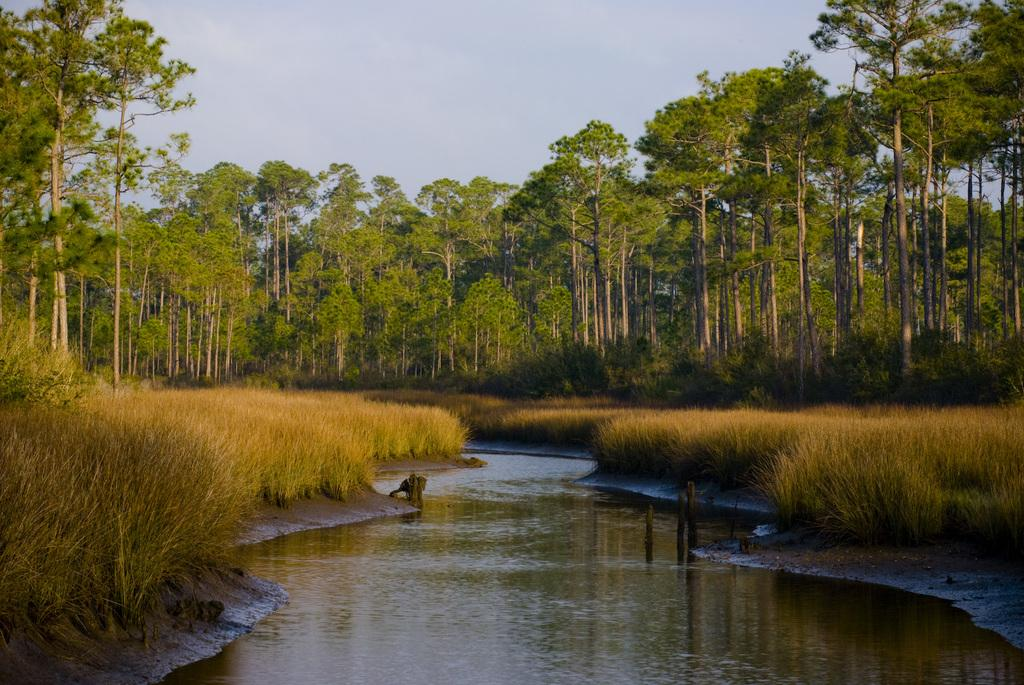What type of vegetation can be seen in the image? There are trees and plants in the image. What natural element is visible in the image? Water is visible in the image. What is visible in the sky in the image? The sky is visible in the image, and clouds are present. What type of coil can be seen in the image? There is no coil present in the image. How many visitors are visible in the image? There are no visitors present in the image. 